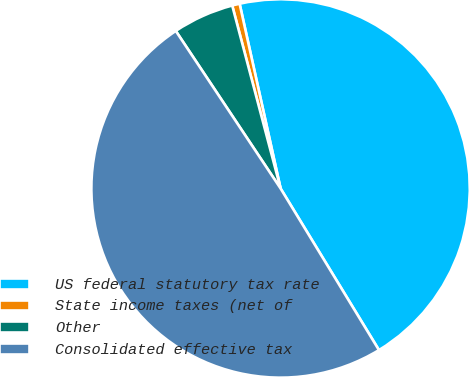<chart> <loc_0><loc_0><loc_500><loc_500><pie_chart><fcel>US federal statutory tax rate<fcel>State income taxes (net of<fcel>Other<fcel>Consolidated effective tax<nl><fcel>44.77%<fcel>0.64%<fcel>5.23%<fcel>49.36%<nl></chart> 